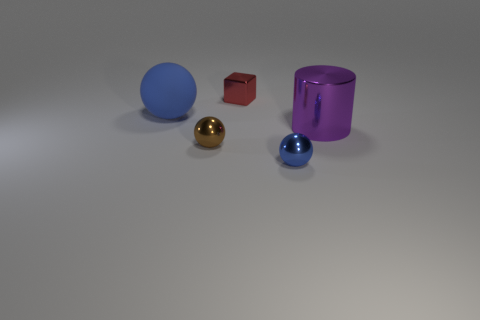Can you infer the arrangement or purpose of these objects? The arrangement of the objects seems random without an apparent purpose, almost like a still life used for artistic composition or visual study. The variety of shapes, colors, and materials could serve as a reference for understanding how light interacts with different surfaces or for practicing renderings in digital or traditional art. 